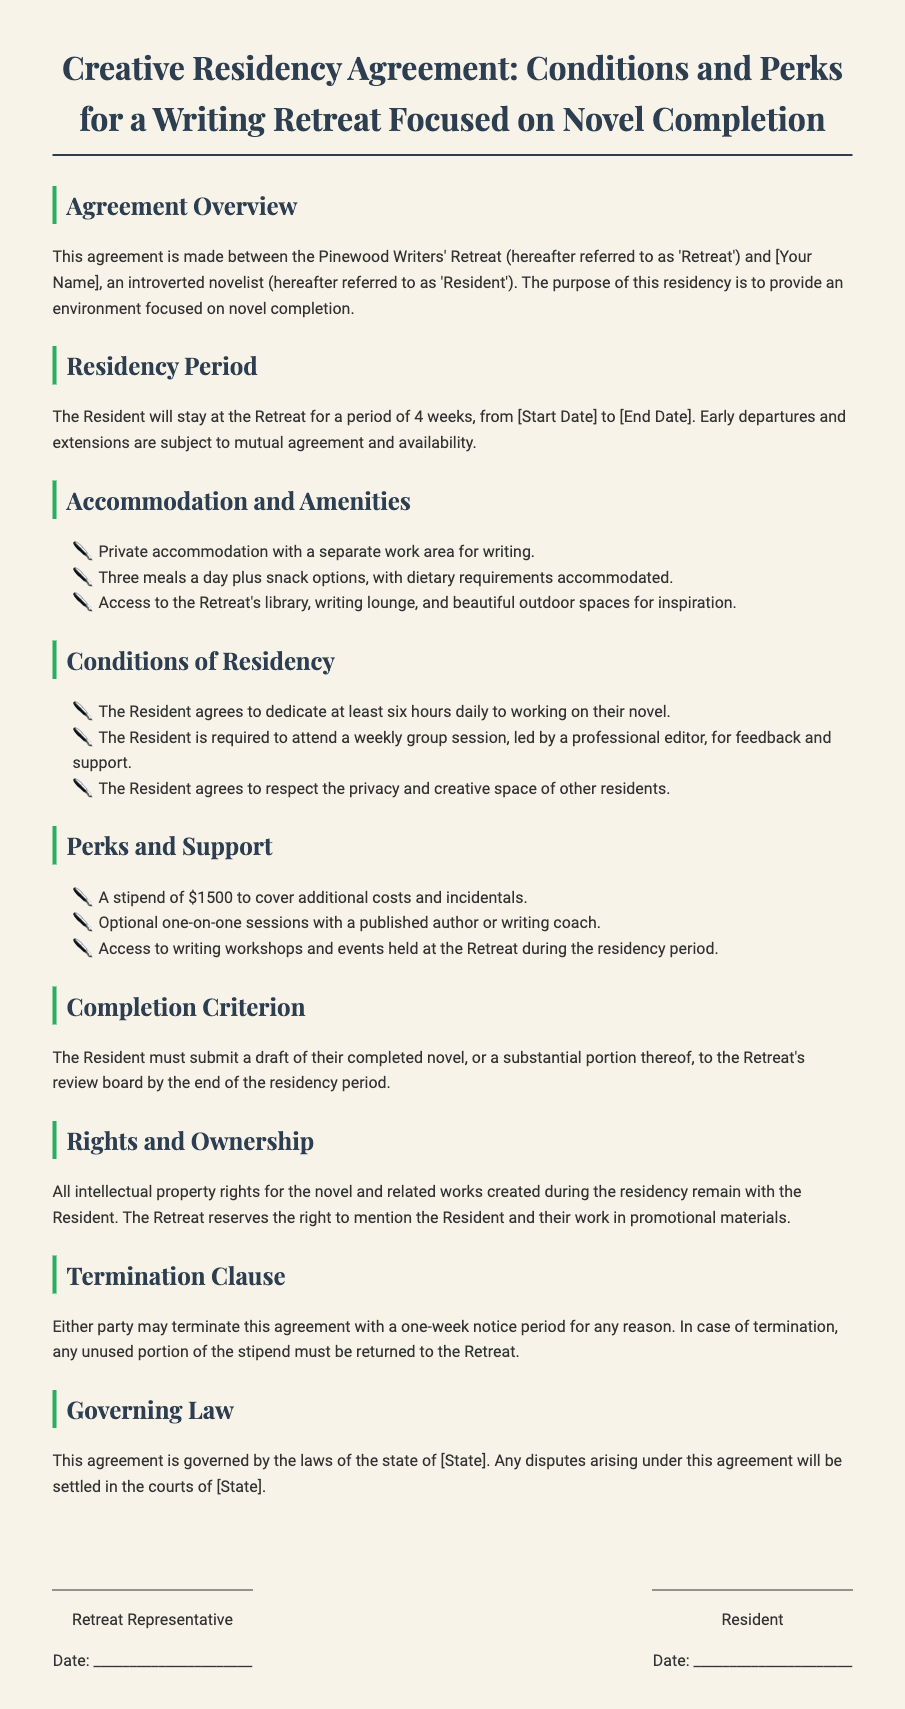What is the duration of the residency? The residency period is specified in the document as 4 weeks.
Answer: 4 weeks What is the stipend amount provided to the Resident? The document states that the Resident will receive a stipend to cover costs, which is specified as $1500.
Answer: $1500 What type of accommodation will the Resident have? The document mentions that the Resident will have private accommodation offered during the stay.
Answer: Private accommodation What is the required daily writing commitment for the Resident? The document specifies that the Resident must dedicate at least six hours daily to working on their novel.
Answer: Six hours What must the Resident submit at the end of the residency? The document states that the Resident must submit a draft of their completed novel, or a substantial portion thereof, to the review board.
Answer: Draft of their completed novel What is the governing law mentioned in the agreement? The governing law is mentioned in the document and pertains to the state where the Retreat is located, specifically noted as [State].
Answer: [State] What must be done if either party wishes to terminate the agreement? The document outlines that either party must give a one-week notice to terminate the agreement.
Answer: One-week notice What does the Retreat reserve the right to do regarding the Resident's work? The Retreat reserves the right to mention the Resident and their work in promotional materials as stated in the document.
Answer: Mention in promotional materials 